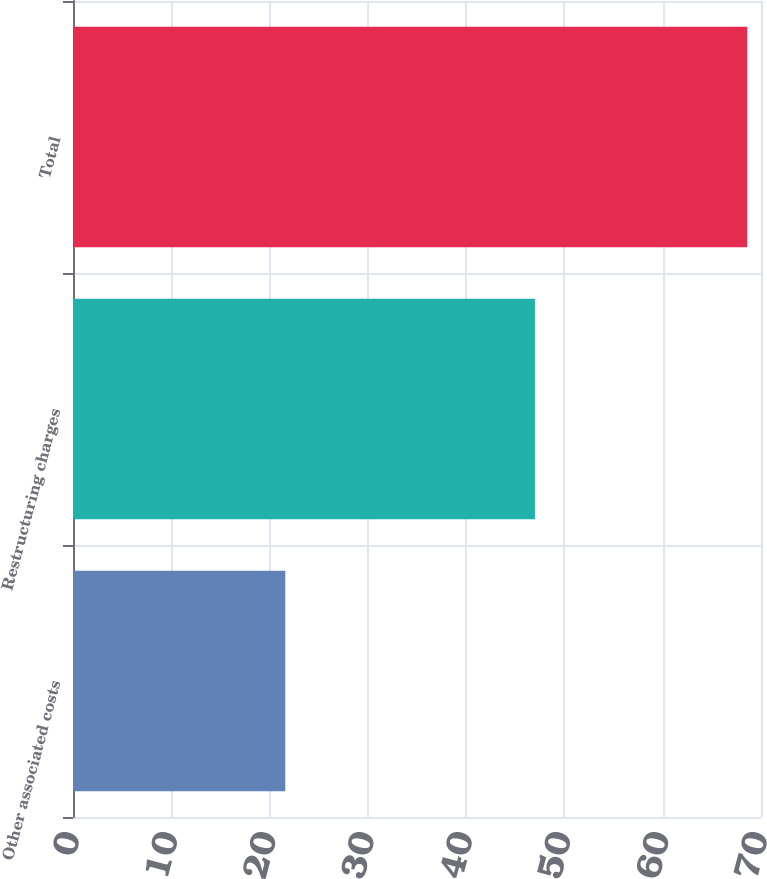Convert chart to OTSL. <chart><loc_0><loc_0><loc_500><loc_500><bar_chart><fcel>Other associated costs<fcel>Restructuring charges<fcel>Total<nl><fcel>21.6<fcel>47<fcel>68.6<nl></chart> 